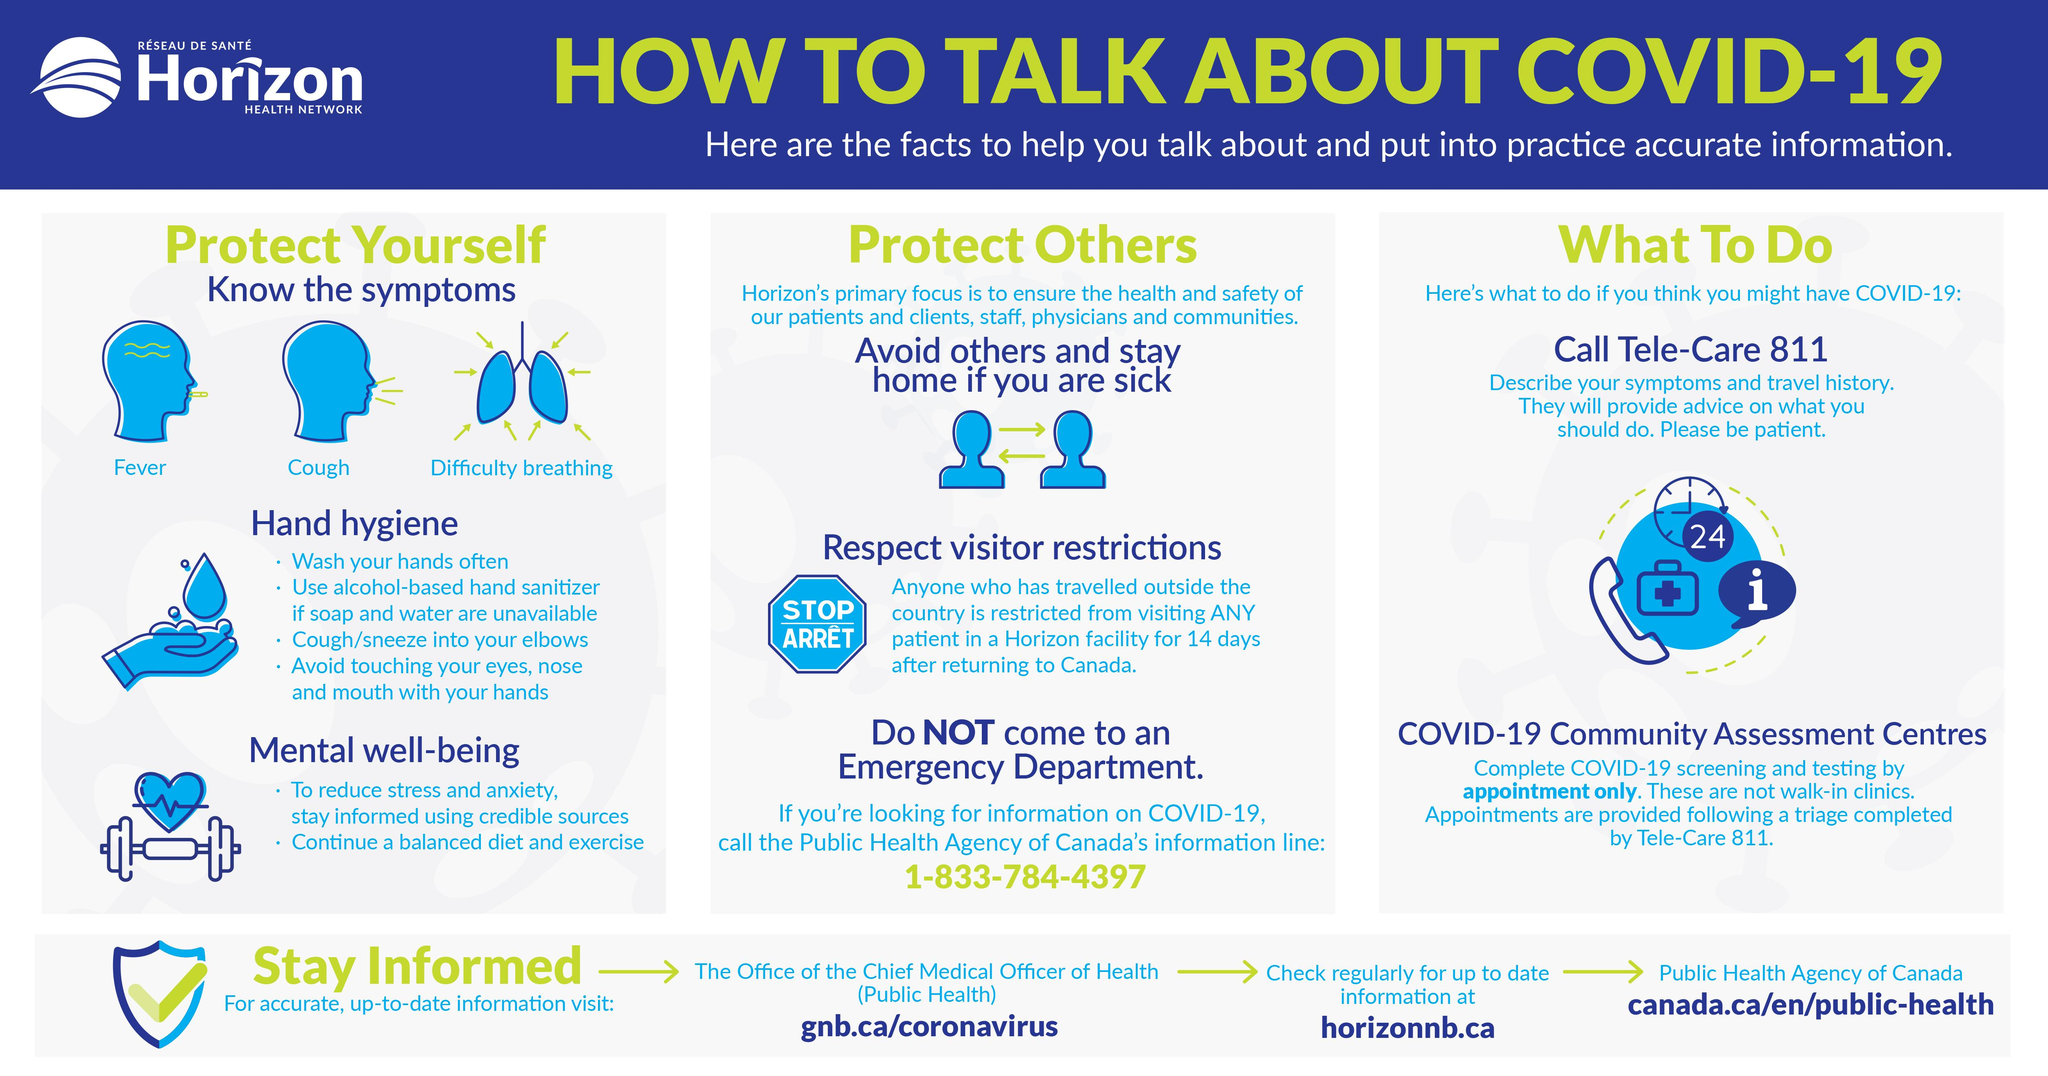Highlight a few significant elements in this photo. There are two points under the heading of Mental Well-being. Hand hygiene is a crucial aspect with 4 points under its heading. The symptoms of COVID-19 include fever, cough, and difficulty breathing. The number written in the clock is 24. 